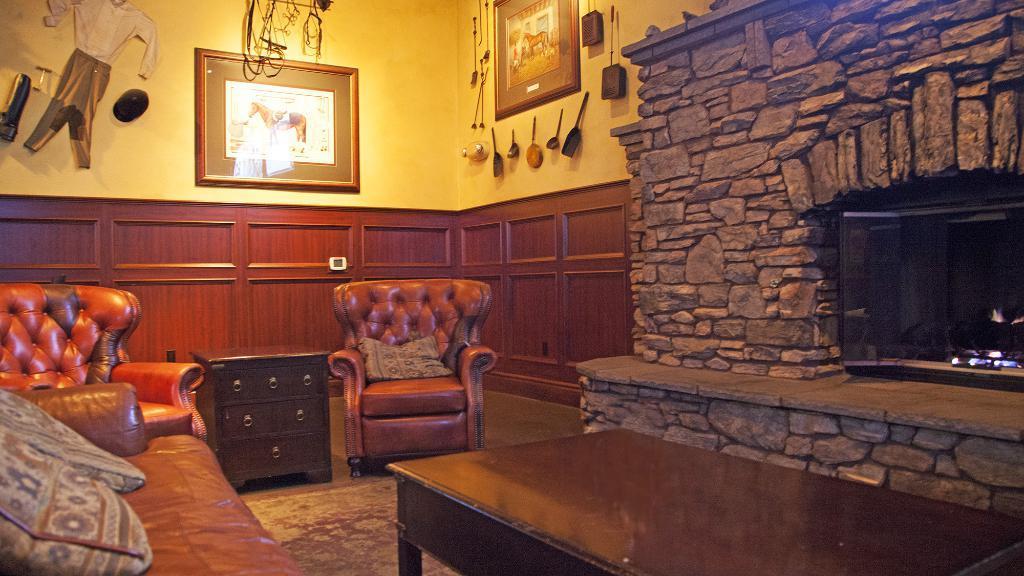Describe this image in one or two sentences. It is a closed room and one sofa set is there and one table and small table with shelves are there. Behind the sofa there is a wooden wall and right of the picture there is a fire place built with stones and beside it there is a wall with some things hanged on it and a picture and another picture and some clothes hanged to the wall. 